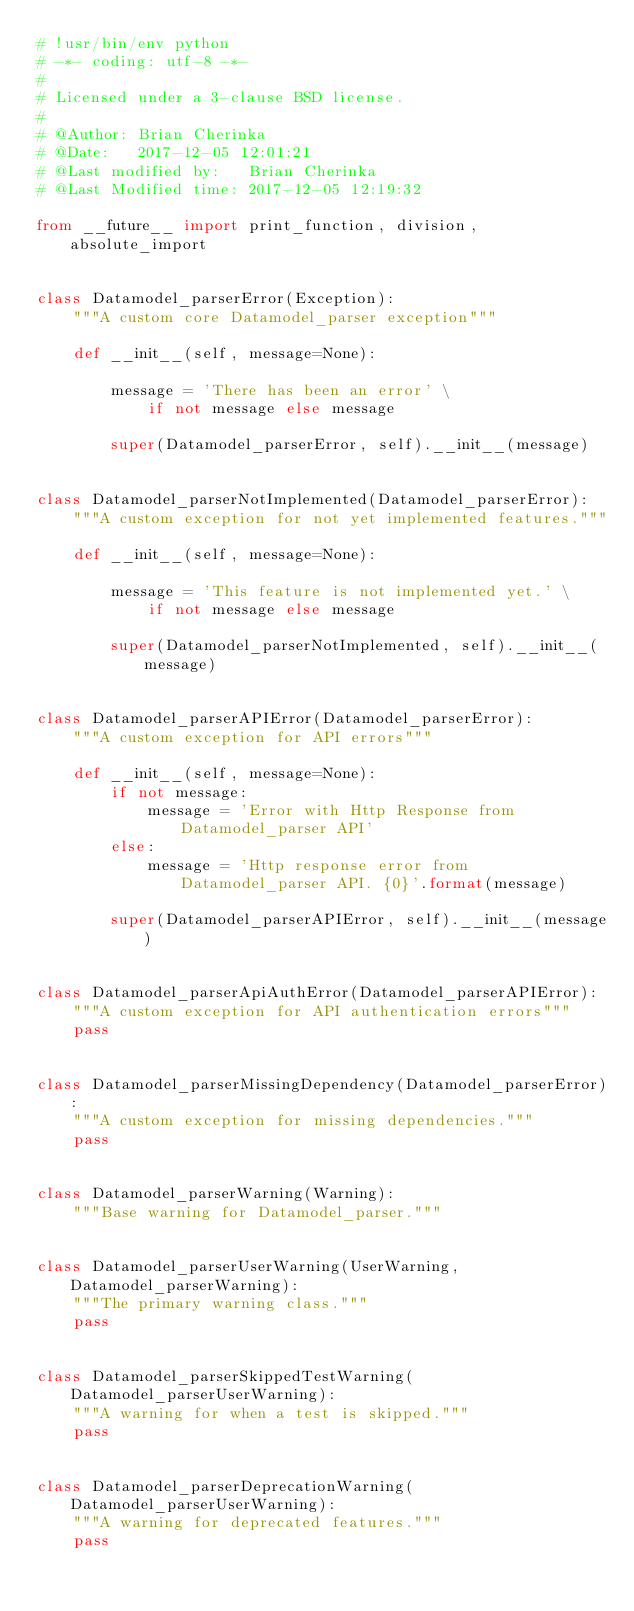Convert code to text. <code><loc_0><loc_0><loc_500><loc_500><_Python_># !usr/bin/env python
# -*- coding: utf-8 -*-
#
# Licensed under a 3-clause BSD license.
#
# @Author: Brian Cherinka
# @Date:   2017-12-05 12:01:21
# @Last modified by:   Brian Cherinka
# @Last Modified time: 2017-12-05 12:19:32

from __future__ import print_function, division, absolute_import


class Datamodel_parserError(Exception):
    """A custom core Datamodel_parser exception"""

    def __init__(self, message=None):

        message = 'There has been an error' \
            if not message else message

        super(Datamodel_parserError, self).__init__(message)


class Datamodel_parserNotImplemented(Datamodel_parserError):
    """A custom exception for not yet implemented features."""

    def __init__(self, message=None):

        message = 'This feature is not implemented yet.' \
            if not message else message

        super(Datamodel_parserNotImplemented, self).__init__(message)


class Datamodel_parserAPIError(Datamodel_parserError):
    """A custom exception for API errors"""

    def __init__(self, message=None):
        if not message:
            message = 'Error with Http Response from Datamodel_parser API'
        else:
            message = 'Http response error from Datamodel_parser API. {0}'.format(message)

        super(Datamodel_parserAPIError, self).__init__(message)


class Datamodel_parserApiAuthError(Datamodel_parserAPIError):
    """A custom exception for API authentication errors"""
    pass


class Datamodel_parserMissingDependency(Datamodel_parserError):
    """A custom exception for missing dependencies."""
    pass


class Datamodel_parserWarning(Warning):
    """Base warning for Datamodel_parser."""


class Datamodel_parserUserWarning(UserWarning, Datamodel_parserWarning):
    """The primary warning class."""
    pass


class Datamodel_parserSkippedTestWarning(Datamodel_parserUserWarning):
    """A warning for when a test is skipped."""
    pass


class Datamodel_parserDeprecationWarning(Datamodel_parserUserWarning):
    """A warning for deprecated features."""
    pass
</code> 